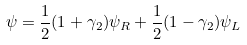<formula> <loc_0><loc_0><loc_500><loc_500>\psi = \frac { 1 } { 2 } ( 1 + \gamma _ { 2 } ) \psi _ { R } + \frac { 1 } { 2 } ( 1 - \gamma _ { 2 } ) \psi _ { L }</formula> 